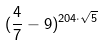Convert formula to latex. <formula><loc_0><loc_0><loc_500><loc_500>( \frac { 4 } { 7 } - 9 ) ^ { 2 0 4 \cdot \sqrt { 5 } }</formula> 